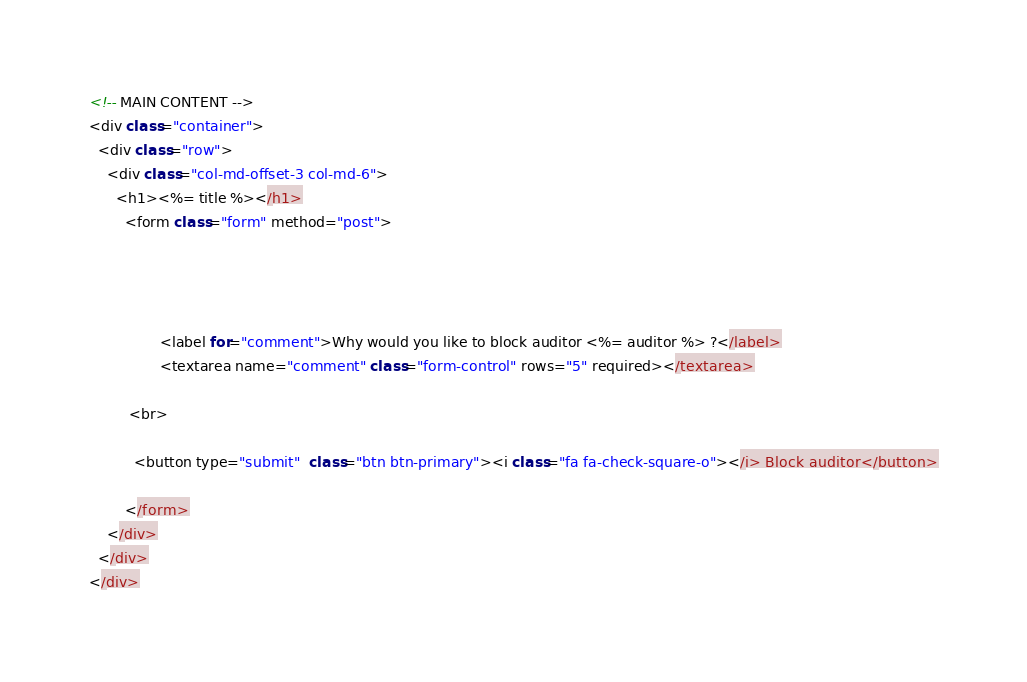Convert code to text. <code><loc_0><loc_0><loc_500><loc_500><_JavaScript_><!-- MAIN CONTENT -->
<div class="container">
  <div class="row">
    <div class="col-md-offset-3 col-md-6">
      <h1><%= title %></h1>
        <form class="form" method="post">
          

          
            
                <label for="comment">Why would you like to block auditor <%= auditor %> ?</label>
                <textarea name="comment" class="form-control" rows="5" required></textarea>
      
         <br>

          <button type="submit"  class="btn btn-primary"><i class="fa fa-check-square-o"></i> Block auditor</button>
          
        </form>
    </div>
  </div>
</div></code> 